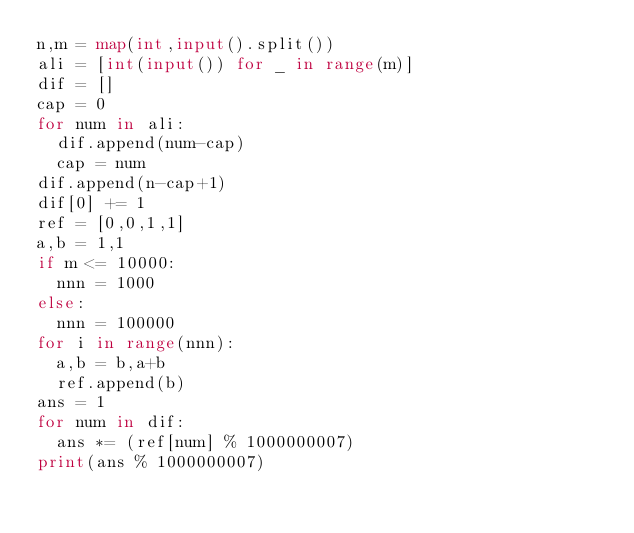<code> <loc_0><loc_0><loc_500><loc_500><_Python_>n,m = map(int,input().split())
ali = [int(input()) for _ in range(m)]
dif = []
cap = 0
for num in ali:
  dif.append(num-cap)
  cap = num
dif.append(n-cap+1)
dif[0] += 1
ref = [0,0,1,1]
a,b = 1,1
if m <= 10000:
  nnn = 1000
else:
  nnn = 100000
for i in range(nnn):
  a,b = b,a+b 
  ref.append(b)
ans = 1
for num in dif:
  ans *= (ref[num] % 1000000007)
print(ans % 1000000007)</code> 